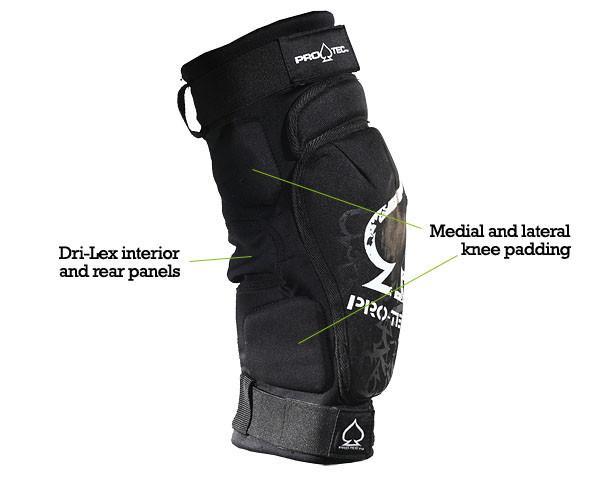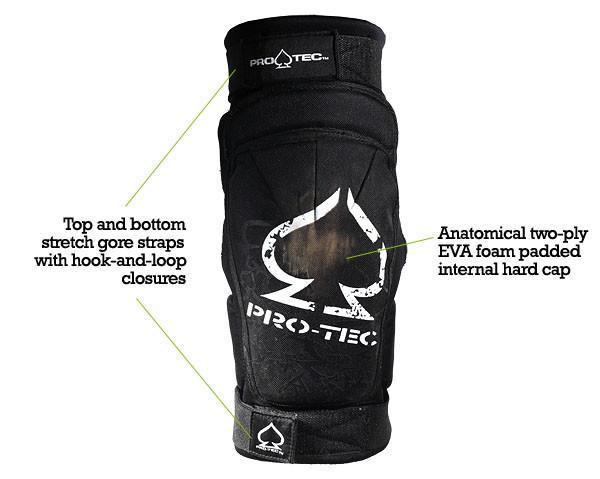The first image is the image on the left, the second image is the image on the right. Given the left and right images, does the statement "Both images contain a pair of all black knee pads" hold true? Answer yes or no. No. The first image is the image on the left, the second image is the image on the right. Assess this claim about the two images: "Both knee pads are facing to the right". Correct or not? Answer yes or no. No. 